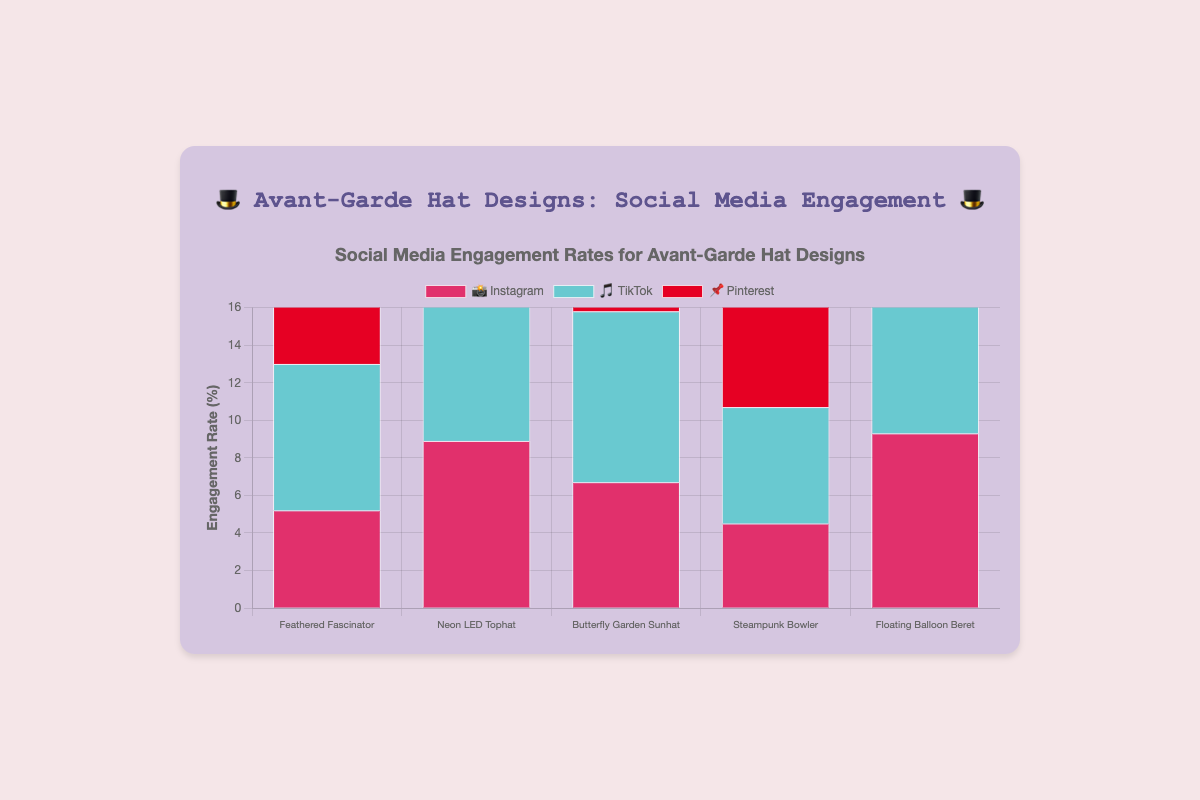Which hat design has the highest engagement rate on TikTok 🎵? Looking at the bars for TikTok, the hat design with the tallest bar is the "Floating Balloon Beret" with an engagement rate of 14.7%.
Answer: Floating Balloon Beret What's the overall trend for Instagram 📸 engagement rates across all hat designs? Observing the bars for Instagram across all hat designs, the trend shows varying engagement rates with the "Floating Balloon Beret" having the highest rate at 9.3% and "Steampunk Bowler" having the lowest at 4.5%.
Answer: Varies with high on Floating Balloon Beret and low on Steampunk Bowler Which platform has the highest average engagement rate for the "Butterfly Garden Sunhat"? Calculate the average of the engagement rates for Instagram (6.7%), TikTok (9.1%), and Pinterest (8.2%). The highest rate is from TikTok at 9.1%.
Answer: TikTok How does the engagement rate of "Steampunk Bowler" on TikTok 🎵 compare to Instagram 📸? Compare the engagement rates of "Steampunk Bowler" on TikTok (6.2%) and Instagram (4.5%). TikTok has a higher engagement rate.
Answer: TikTok is higher Which hat design has the lowest engagement rate on any platform 📌? From the chart, the "Feathered Fascinator" on Pinterest has the lowest rate at 4.1%.
Answer: Feathered Fascinator What is the difference in engagement rates between the "Neon LED Tophat" and "Floating Balloon Beret" on Pinterest 📌? Subtract the engagement rate of "Neon LED Tophat" (6.5%) from "Floating Balloon Beret" (7.9%). The difference is 1.4%.
Answer: 1.4% Which hat design has consistent engagement rates across all platforms Look for the hat design with the least variation in engagement rates across Instagram, TikTok, and Pinterest. The "Feathered Fascinator" shows relatively consistent rates (5.2%, 7.8%, 4.1%) compared to others.
Answer: Feathered Fascinator How does the engagement rate trend for "Neon LED Tophat" on Instagram 📸 differ from Pinterest 📌? Compare bar heights. Instagram has a higher engagement rate (8.9%) than Pinterest (6.5%). The trend indicates "Neon LED Tophat" is preferred more on Instagram.
Answer: Instagram is higher 